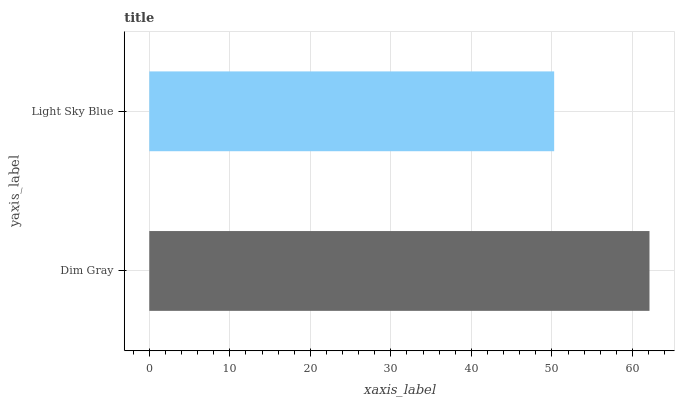Is Light Sky Blue the minimum?
Answer yes or no. Yes. Is Dim Gray the maximum?
Answer yes or no. Yes. Is Light Sky Blue the maximum?
Answer yes or no. No. Is Dim Gray greater than Light Sky Blue?
Answer yes or no. Yes. Is Light Sky Blue less than Dim Gray?
Answer yes or no. Yes. Is Light Sky Blue greater than Dim Gray?
Answer yes or no. No. Is Dim Gray less than Light Sky Blue?
Answer yes or no. No. Is Dim Gray the high median?
Answer yes or no. Yes. Is Light Sky Blue the low median?
Answer yes or no. Yes. Is Light Sky Blue the high median?
Answer yes or no. No. Is Dim Gray the low median?
Answer yes or no. No. 